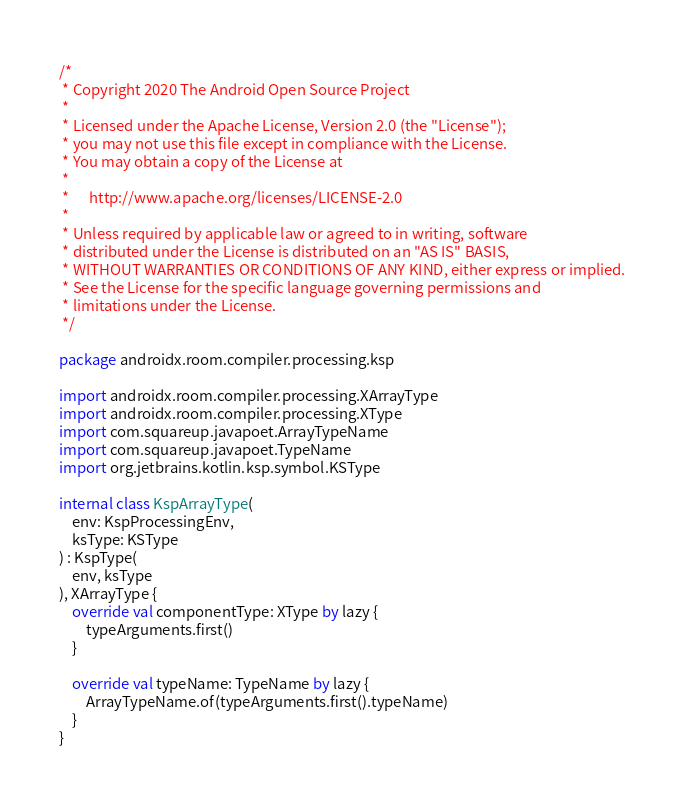<code> <loc_0><loc_0><loc_500><loc_500><_Kotlin_>/*
 * Copyright 2020 The Android Open Source Project
 *
 * Licensed under the Apache License, Version 2.0 (the "License");
 * you may not use this file except in compliance with the License.
 * You may obtain a copy of the License at
 *
 *      http://www.apache.org/licenses/LICENSE-2.0
 *
 * Unless required by applicable law or agreed to in writing, software
 * distributed under the License is distributed on an "AS IS" BASIS,
 * WITHOUT WARRANTIES OR CONDITIONS OF ANY KIND, either express or implied.
 * See the License for the specific language governing permissions and
 * limitations under the License.
 */

package androidx.room.compiler.processing.ksp

import androidx.room.compiler.processing.XArrayType
import androidx.room.compiler.processing.XType
import com.squareup.javapoet.ArrayTypeName
import com.squareup.javapoet.TypeName
import org.jetbrains.kotlin.ksp.symbol.KSType

internal class KspArrayType(
    env: KspProcessingEnv,
    ksType: KSType
) : KspType(
    env, ksType
), XArrayType {
    override val componentType: XType by lazy {
        typeArguments.first()
    }

    override val typeName: TypeName by lazy {
        ArrayTypeName.of(typeArguments.first().typeName)
    }
}
</code> 